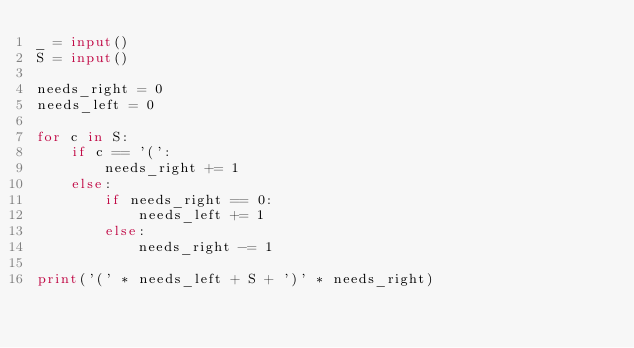Convert code to text. <code><loc_0><loc_0><loc_500><loc_500><_Python_>_ = input()
S = input()

needs_right = 0
needs_left = 0

for c in S:
    if c == '(':
        needs_right += 1
    else:
        if needs_right == 0:
            needs_left += 1
        else:
            needs_right -= 1

print('(' * needs_left + S + ')' * needs_right)

</code> 